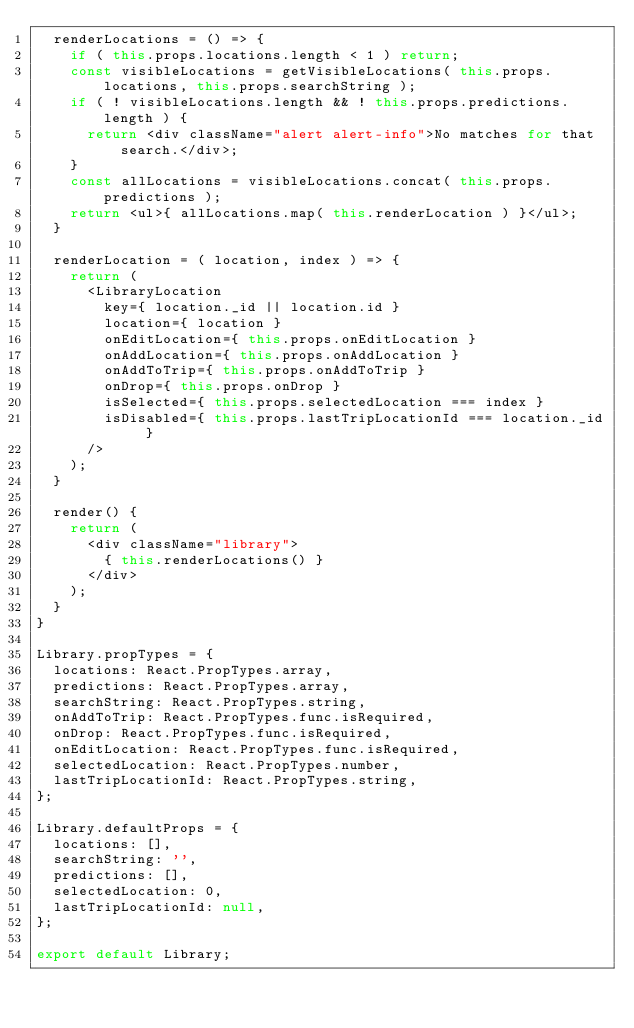<code> <loc_0><loc_0><loc_500><loc_500><_JavaScript_>  renderLocations = () => {
    if ( this.props.locations.length < 1 ) return;
    const visibleLocations = getVisibleLocations( this.props.locations, this.props.searchString );
    if ( ! visibleLocations.length && ! this.props.predictions.length ) {
      return <div className="alert alert-info">No matches for that search.</div>;
    }
    const allLocations = visibleLocations.concat( this.props.predictions );
    return <ul>{ allLocations.map( this.renderLocation ) }</ul>;
  }

  renderLocation = ( location, index ) => {
    return (
      <LibraryLocation
        key={ location._id || location.id }
        location={ location }
        onEditLocation={ this.props.onEditLocation }
        onAddLocation={ this.props.onAddLocation }
        onAddToTrip={ this.props.onAddToTrip }
        onDrop={ this.props.onDrop }
        isSelected={ this.props.selectedLocation === index }
        isDisabled={ this.props.lastTripLocationId === location._id }
      />
    );
  }

  render() {
    return (
      <div className="library">
        { this.renderLocations() }
      </div>
    );
  }
}

Library.propTypes = {
  locations: React.PropTypes.array,
  predictions: React.PropTypes.array,
  searchString: React.PropTypes.string,
  onAddToTrip: React.PropTypes.func.isRequired,
  onDrop: React.PropTypes.func.isRequired,
  onEditLocation: React.PropTypes.func.isRequired,
  selectedLocation: React.PropTypes.number,
  lastTripLocationId: React.PropTypes.string,
};

Library.defaultProps = {
  locations: [],
  searchString: '',
  predictions: [],
  selectedLocation: 0,
  lastTripLocationId: null,
};

export default Library;
</code> 